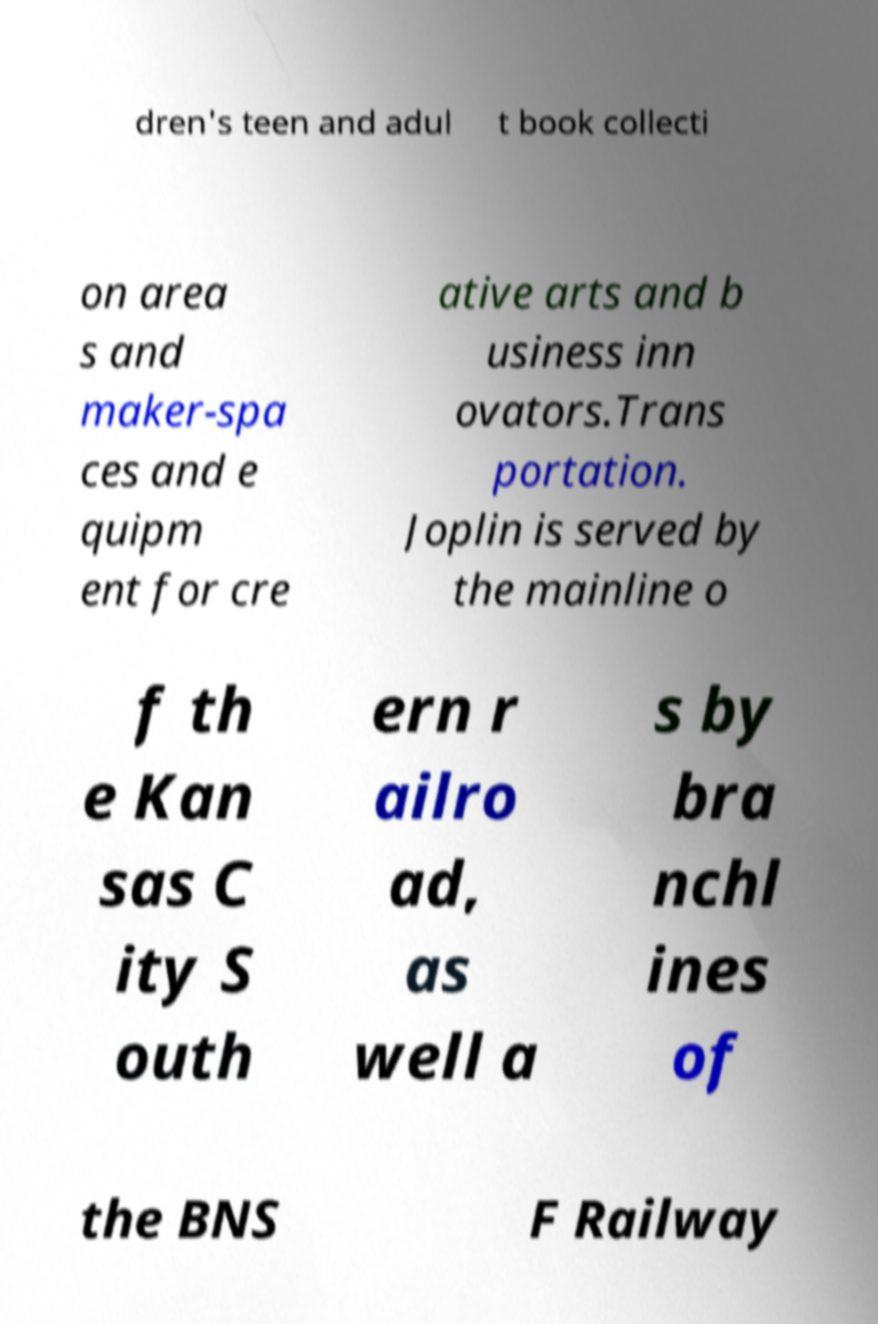Could you extract and type out the text from this image? dren's teen and adul t book collecti on area s and maker-spa ces and e quipm ent for cre ative arts and b usiness inn ovators.Trans portation. Joplin is served by the mainline o f th e Kan sas C ity S outh ern r ailro ad, as well a s by bra nchl ines of the BNS F Railway 